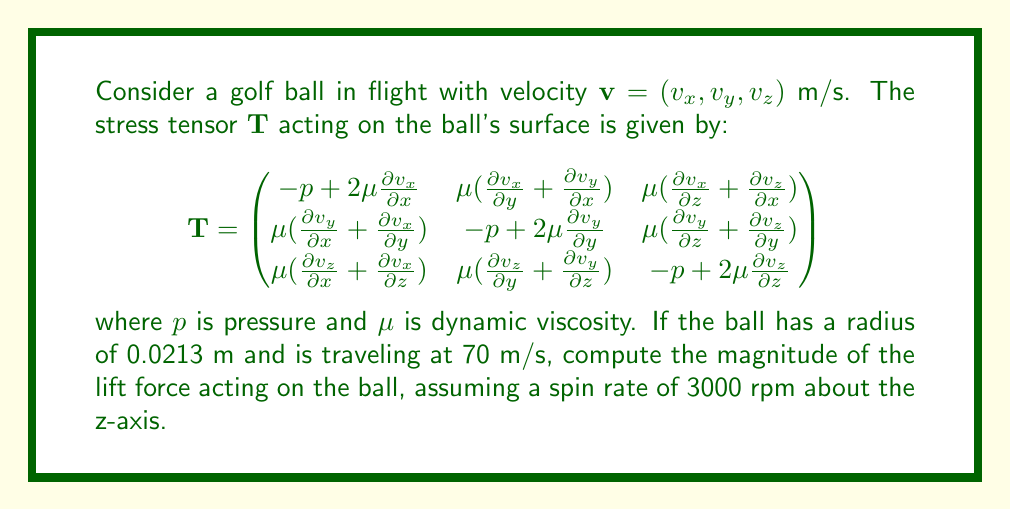Teach me how to tackle this problem. To solve this problem, we'll follow these steps:

1) The lift force on a spinning golf ball is primarily due to the Magnus effect. The Magnus force is given by:

   $\mathbf{F}_M = \frac{1}{2}\rho A C_L (\mathbf{\omega} \times \mathbf{v})$

   where $\rho$ is air density, $A$ is cross-sectional area, $C_L$ is the lift coefficient, $\mathbf{\omega}$ is angular velocity, and $\mathbf{v}$ is velocity.

2) Calculate the cross-sectional area:
   $A = \pi r^2 = \pi (0.0213)^2 = 0.00143 \text{ m}^2$

3) Convert spin rate to angular velocity:
   $\omega = 3000 \text{ rpm} = 3000 \cdot \frac{2\pi}{60} = 314.16 \text{ rad/s}$

4) The angular velocity vector is $\mathbf{\omega} = (0, 0, 314.16)$ rad/s

5) The velocity vector is $\mathbf{v} = (70, 0, 0)$ m/s (assuming the ball is traveling in the x-direction)

6) Calculate $\mathbf{\omega} \times \mathbf{v}$:
   $\mathbf{\omega} \times \mathbf{v} = (0, -22291.2, 0)$

7) The magnitude of $\mathbf{\omega} \times \mathbf{v}$ is 22291.2 m^2/s^2

8) For a golf ball, $C_L$ is typically around 0.1, and air density $\rho$ is approximately 1.225 kg/m^3

9) Plugging these values into the Magnus force equation:

   $|\mathbf{F}_M| = \frac{1}{2} \cdot 1.225 \cdot 0.00143 \cdot 0.1 \cdot 22291.2 = 1.95 \text{ N}$

Therefore, the magnitude of the lift force acting on the golf ball is approximately 1.95 N.
Answer: 1.95 N 